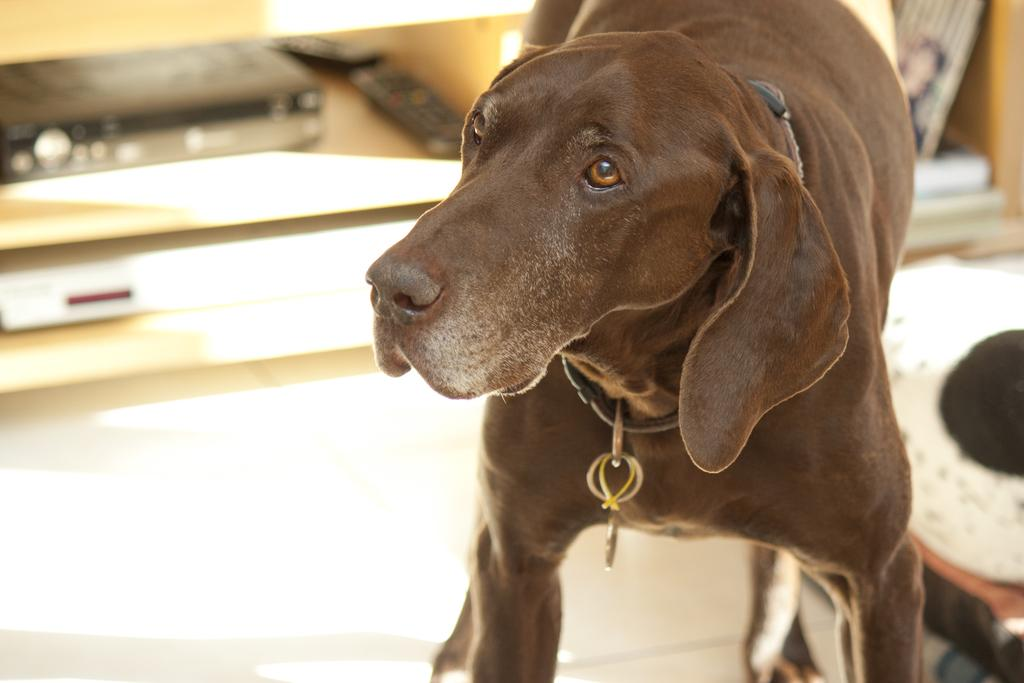What is the main subject of the picture? The main subject of the picture is a dog. Can you describe the dog's appearance? The dog is chocolate-colored. What can be observed about the background of the image? The background of the image is blurred. Where is the pear located in the image? There is no pear present in the image. What type of vase can be seen in the image? There is no vase present in the image. 